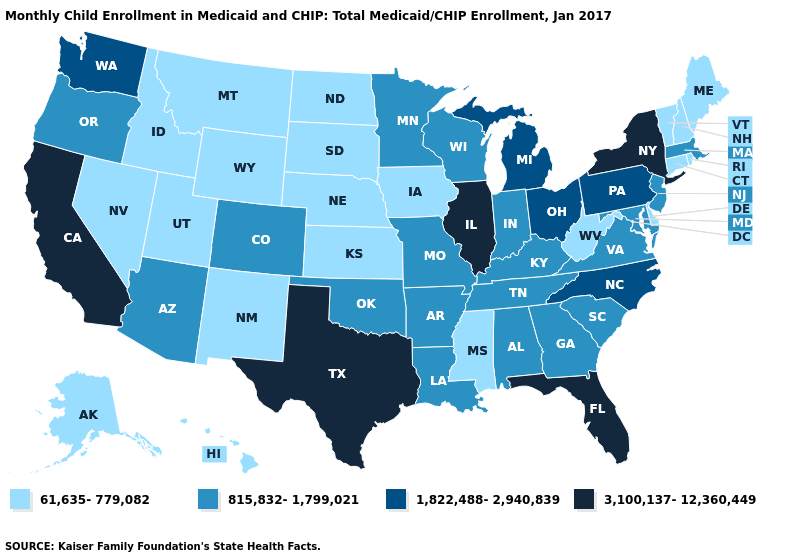What is the value of Alaska?
Give a very brief answer. 61,635-779,082. Name the states that have a value in the range 3,100,137-12,360,449?
Be succinct. California, Florida, Illinois, New York, Texas. Does North Carolina have the same value as Kansas?
Concise answer only. No. What is the value of California?
Answer briefly. 3,100,137-12,360,449. Does New York have the highest value in the Northeast?
Quick response, please. Yes. Does Georgia have a higher value than Montana?
Quick response, please. Yes. Name the states that have a value in the range 815,832-1,799,021?
Answer briefly. Alabama, Arizona, Arkansas, Colorado, Georgia, Indiana, Kentucky, Louisiana, Maryland, Massachusetts, Minnesota, Missouri, New Jersey, Oklahoma, Oregon, South Carolina, Tennessee, Virginia, Wisconsin. Name the states that have a value in the range 61,635-779,082?
Concise answer only. Alaska, Connecticut, Delaware, Hawaii, Idaho, Iowa, Kansas, Maine, Mississippi, Montana, Nebraska, Nevada, New Hampshire, New Mexico, North Dakota, Rhode Island, South Dakota, Utah, Vermont, West Virginia, Wyoming. Name the states that have a value in the range 815,832-1,799,021?
Write a very short answer. Alabama, Arizona, Arkansas, Colorado, Georgia, Indiana, Kentucky, Louisiana, Maryland, Massachusetts, Minnesota, Missouri, New Jersey, Oklahoma, Oregon, South Carolina, Tennessee, Virginia, Wisconsin. Name the states that have a value in the range 61,635-779,082?
Quick response, please. Alaska, Connecticut, Delaware, Hawaii, Idaho, Iowa, Kansas, Maine, Mississippi, Montana, Nebraska, Nevada, New Hampshire, New Mexico, North Dakota, Rhode Island, South Dakota, Utah, Vermont, West Virginia, Wyoming. What is the value of Hawaii?
Quick response, please. 61,635-779,082. What is the lowest value in the USA?
Quick response, please. 61,635-779,082. Name the states that have a value in the range 61,635-779,082?
Answer briefly. Alaska, Connecticut, Delaware, Hawaii, Idaho, Iowa, Kansas, Maine, Mississippi, Montana, Nebraska, Nevada, New Hampshire, New Mexico, North Dakota, Rhode Island, South Dakota, Utah, Vermont, West Virginia, Wyoming. What is the value of New Hampshire?
Give a very brief answer. 61,635-779,082. What is the value of North Carolina?
Answer briefly. 1,822,488-2,940,839. 